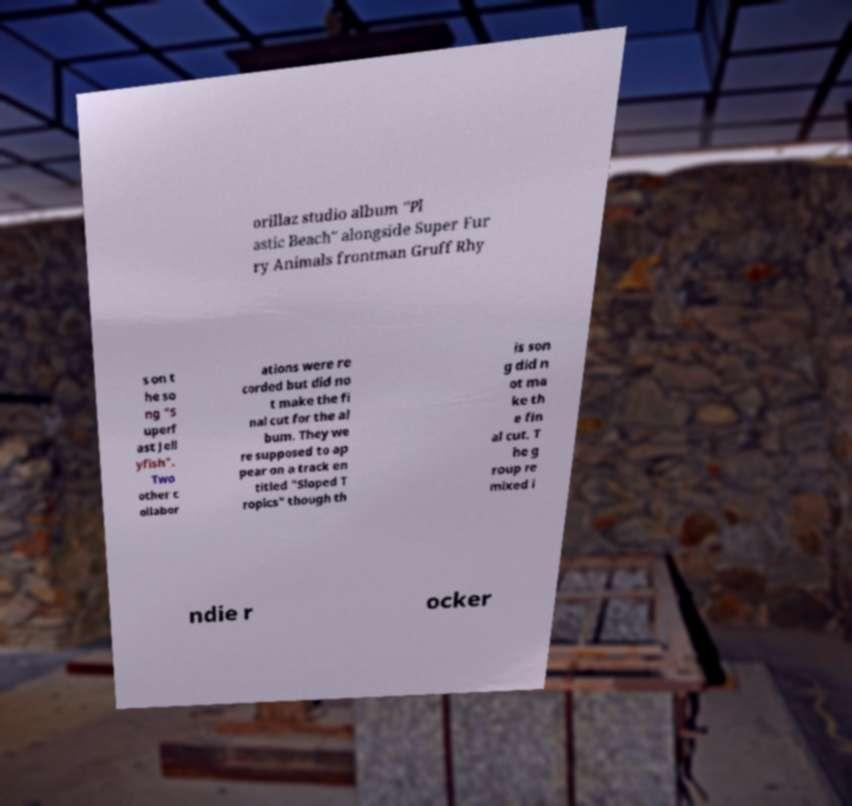Could you assist in decoding the text presented in this image and type it out clearly? orillaz studio album "Pl astic Beach" alongside Super Fur ry Animals frontman Gruff Rhy s on t he so ng "S uperf ast Jell yfish". Two other c ollabor ations were re corded but did no t make the fi nal cut for the al bum. They we re supposed to ap pear on a track en titled "Sloped T ropics" though th is son g did n ot ma ke th e fin al cut. T he g roup re mixed i ndie r ocker 